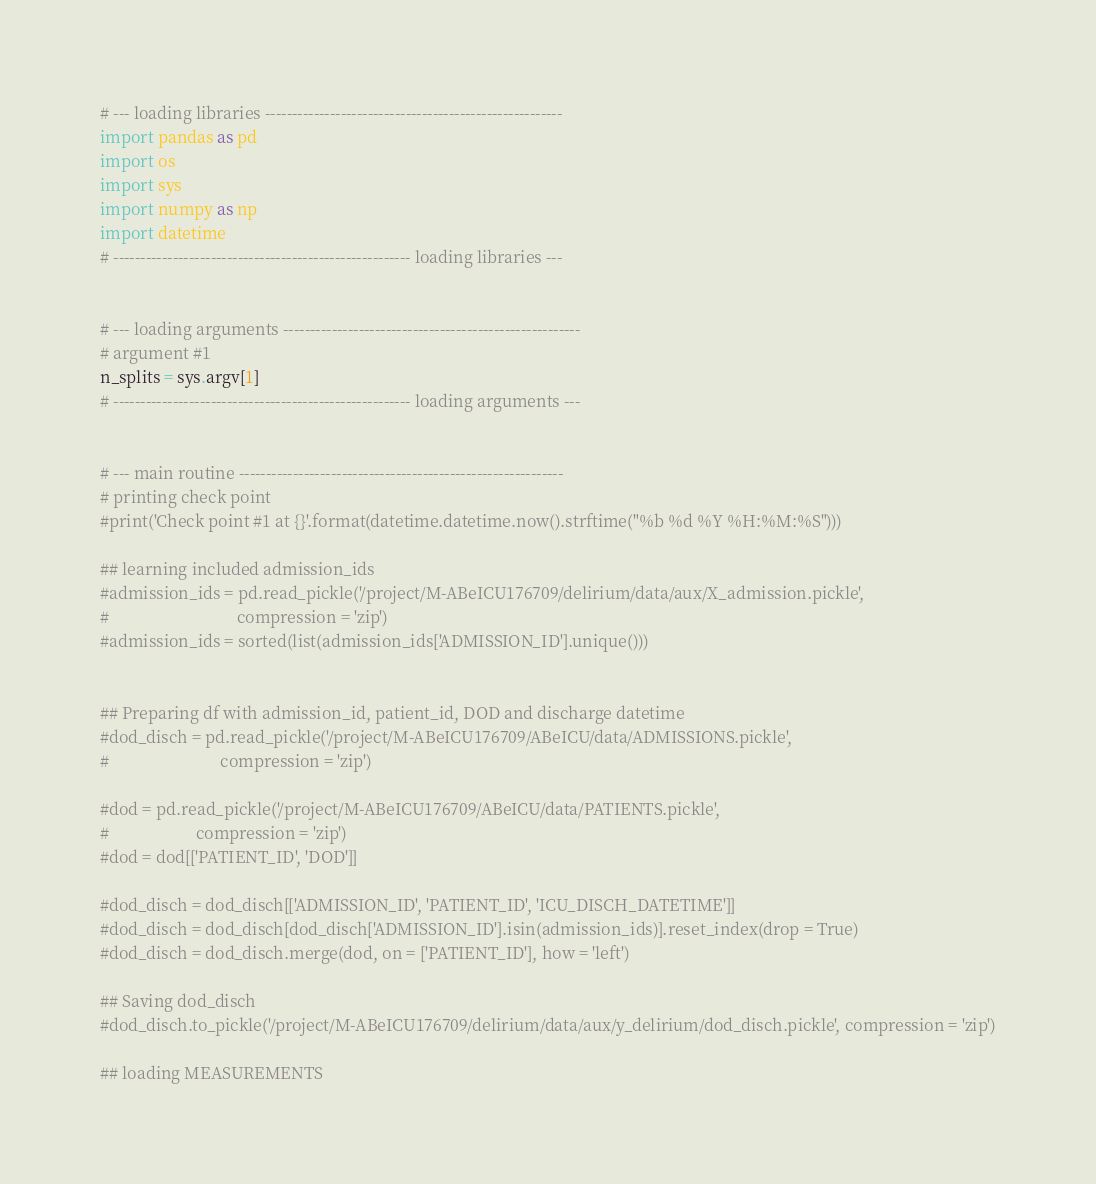Convert code to text. <code><loc_0><loc_0><loc_500><loc_500><_Python_>

# --- loading libraries -------------------------------------------------------
import pandas as pd
import os
import sys
import numpy as np
import datetime
# ------------------------------------------------------- loading libraries ---


# --- loading arguments -------------------------------------------------------
# argument #1
n_splits = sys.argv[1]
# ------------------------------------------------------- loading arguments ---


# --- main routine ------------------------------------------------------------
# printing check point
#print('Check point #1 at {}'.format(datetime.datetime.now().strftime("%b %d %Y %H:%M:%S")))

## learning included admission_ids
#admission_ids = pd.read_pickle('/project/M-ABeICU176709/delirium/data/aux/X_admission.pickle',
#                               compression = 'zip')
#admission_ids = sorted(list(admission_ids['ADMISSION_ID'].unique()))


## Preparing df with admission_id, patient_id, DOD and discharge datetime
#dod_disch = pd.read_pickle('/project/M-ABeICU176709/ABeICU/data/ADMISSIONS.pickle',
#                           compression = 'zip')

#dod = pd.read_pickle('/project/M-ABeICU176709/ABeICU/data/PATIENTS.pickle',
#                     compression = 'zip')
#dod = dod[['PATIENT_ID', 'DOD']]

#dod_disch = dod_disch[['ADMISSION_ID', 'PATIENT_ID', 'ICU_DISCH_DATETIME']]
#dod_disch = dod_disch[dod_disch['ADMISSION_ID'].isin(admission_ids)].reset_index(drop = True)
#dod_disch = dod_disch.merge(dod, on = ['PATIENT_ID'], how = 'left')

## Saving dod_disch
#dod_disch.to_pickle('/project/M-ABeICU176709/delirium/data/aux/y_delirium/dod_disch.pickle', compression = 'zip')

## loading MEASUREMENTS</code> 